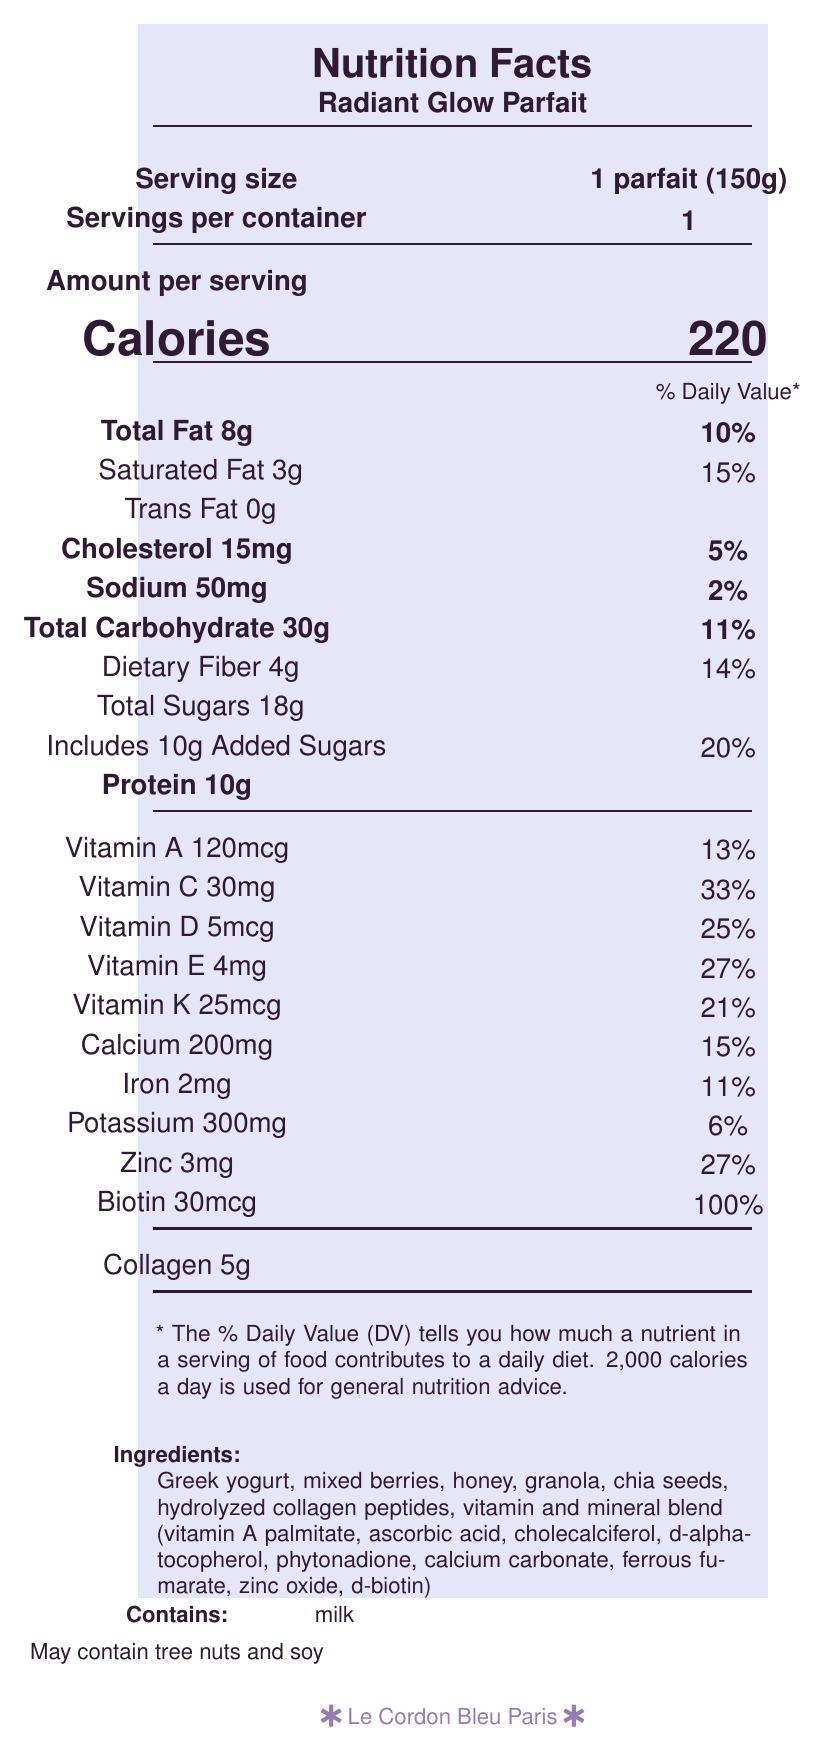What is the serving size of the Radiant Glow Parfait? The serving size is clearly mentioned next to "Serving size" as "1 parfait (150g)".
Answer: 1 parfait (150g) How many calories are in one serving of the Radiant Glow Parfait? The calories per serving are indicated under "Amount per serving" as "Calories 220".
Answer: 220 What percentage of daily value does the saturated fat provide? The daily value percentage for saturated fat is listed next to “Saturated Fat 3g” as "15%".
Answer: 15% How much added sugar does the dessert contain? The amount of added sugars is specified under "Includes 10g Added Sugars".
Answer: 10g What is the total fat content in one serving? The total fat content is displayed under "Total Fat 8g".
Answer: 8g Which of the following vitamins does the parfait provide more than 25% of the daily value? A. Vitamin D B. Vitamin K C. Vitamin E D. Zinc Zinc provides 27% of the daily value, which is more than 25%, while Vitamin D provides 25%, Vitamin K provides 21%, and Vitamin E provides 27%.
Answer: D. Zinc How much protein is in one serving of the Radiant Glow Parfait? The protein content per serving is listed under "Protein 10g".
Answer: 10g Is the parfait suitable for someone with a nut allergy? The document specifies under "Contains" that it may contain tree nuts and soy.
Answer: No What is the main purpose of the Radiant Glow Parfait as highlighted in the document? The project description mentions it was developed focusing on creating functional foods for beauty and wellness.
Answer: Functional foods for beauty and wellness Does the Radiant Glow Parfait contain trans fat? The trans fat content is listed as "0g".
Answer: No Summarize the main features and nutritional benefits of the Radiant Glow Parfait described in the document. This summary consolidates all the key points about the nutritional facts and intended benefits of the Radiant Glow Parfait.
Answer: The Radiant Glow Parfait, developed by Le Cordon Bleu Paris, is a 150g serving dessert rich in various vitamins and minerals. It contains 220 calories with 8g of total fat, 10g of protein, and 30g of carbohydrates. It's enriched with collagen and a vitamin & mineral blend aimed at promoting beauty and wellness. The parfait also highlights high contributions of vitamins C, D, E, K, calcium, iron, potassium, and zinc, making it a nutritious and functional food for maintaining radiant skin and hair suitable for beauty pageants. Refrigeration is required for storage. What culinary school developed the Radiant Glow Parfait? The document states under "culinary_school" that it was developed by "Le Cordon Bleu Paris".
Answer: Le Cordon Bleu Paris Are the ingredients of this dessert clearly listed in the document? The ingredients are clearly listed under "Ingredients," which includes items like Greek yogurt, mixed berries, honey, granola, etc.
Answer: Yes How much biotin does the dessert provide per serving and what is its daily value percentage? The document lists biotin at "30mcg" providing "100% of the daily value."
Answer: 30mcg, 100% How much vitamin C does the Radiant Glow Parfait contain per serving? Vitamin C content is specifically mentioned as "30mg".
Answer: 30mg What percentage of the daily value of iron does this dessert provide? A. 11% B. 15% C. 20% D. 27% The document lists the iron content with a daily value of 11%.
Answer: A. 11% What amount of calcium is in one serving? The calcium amount per serving is stated as "200mg".
Answer: 200mg What is the overall goal of creating the Radiant Glow Parfait? The project description states that it was part of an advanced nutrition and recipe development course, with the aim being functional foods for beauty and wellness. Additionally, it highlights the parfait's benefit for maintaining radiant skin and hair for beauty pageant use.
Answer: To develop functional foods for beauty and wellness, focusing on maintaining radiant skin and hair while staying competition-ready. How much sodium is present in one serving? The sodium content per serving is listed as "50mg".
Answer: 50mg What are the allergens listed in the document? The document specifies "Contains milk" and "May contain tree nuts and soy" under the allergens section.
Answer: Milk, may contain tree nuts and soy Can I determine the cost of the Radiant Glow Parfait from this document? The document provides detailed nutritional information but does not mention the cost.
Answer: Not enough information 